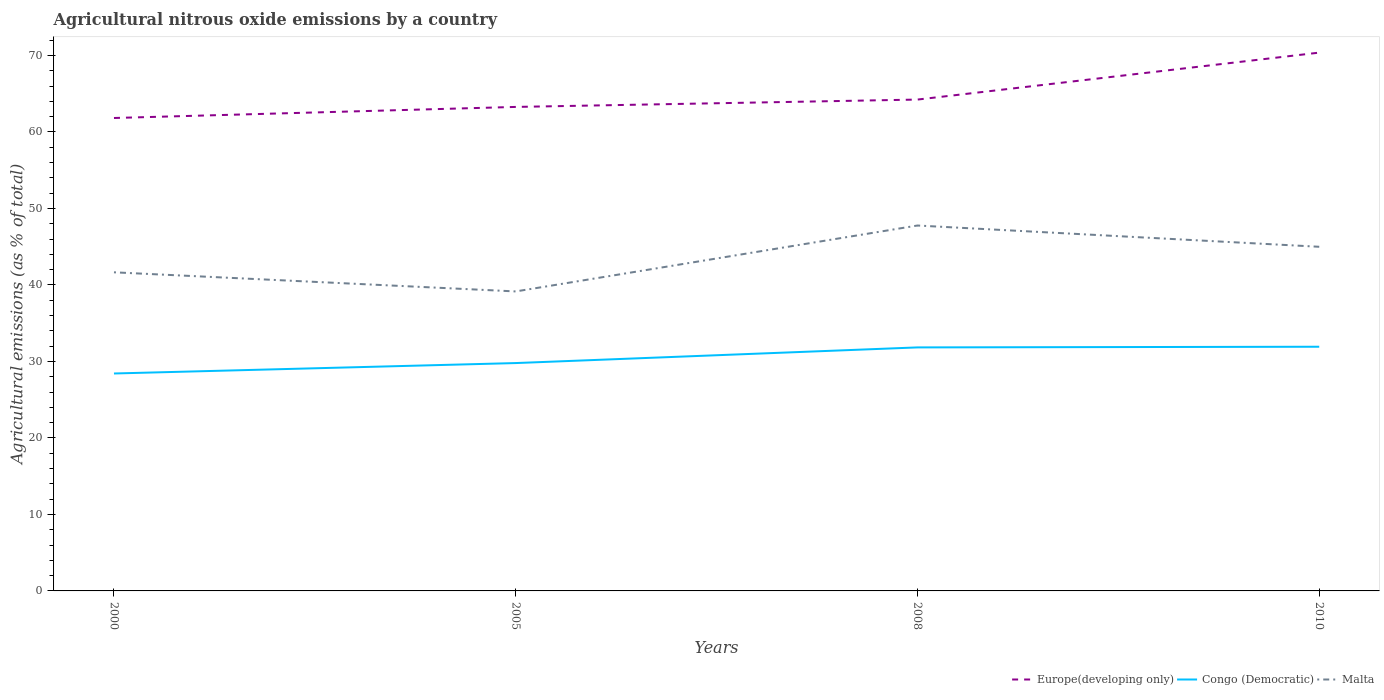Across all years, what is the maximum amount of agricultural nitrous oxide emitted in Malta?
Your answer should be very brief. 39.15. In which year was the amount of agricultural nitrous oxide emitted in Congo (Democratic) maximum?
Make the answer very short. 2000. What is the total amount of agricultural nitrous oxide emitted in Malta in the graph?
Provide a succinct answer. -5.84. What is the difference between the highest and the second highest amount of agricultural nitrous oxide emitted in Malta?
Your response must be concise. 8.62. What is the difference between the highest and the lowest amount of agricultural nitrous oxide emitted in Congo (Democratic)?
Give a very brief answer. 2. Is the amount of agricultural nitrous oxide emitted in Europe(developing only) strictly greater than the amount of agricultural nitrous oxide emitted in Malta over the years?
Offer a terse response. No. Are the values on the major ticks of Y-axis written in scientific E-notation?
Your answer should be compact. No. Does the graph contain grids?
Keep it short and to the point. No. How are the legend labels stacked?
Offer a terse response. Horizontal. What is the title of the graph?
Give a very brief answer. Agricultural nitrous oxide emissions by a country. Does "Malta" appear as one of the legend labels in the graph?
Offer a terse response. Yes. What is the label or title of the X-axis?
Your response must be concise. Years. What is the label or title of the Y-axis?
Your response must be concise. Agricultural emissions (as % of total). What is the Agricultural emissions (as % of total) of Europe(developing only) in 2000?
Offer a very short reply. 61.83. What is the Agricultural emissions (as % of total) of Congo (Democratic) in 2000?
Offer a terse response. 28.43. What is the Agricultural emissions (as % of total) of Malta in 2000?
Provide a succinct answer. 41.65. What is the Agricultural emissions (as % of total) of Europe(developing only) in 2005?
Provide a short and direct response. 63.28. What is the Agricultural emissions (as % of total) in Congo (Democratic) in 2005?
Your answer should be very brief. 29.79. What is the Agricultural emissions (as % of total) of Malta in 2005?
Give a very brief answer. 39.15. What is the Agricultural emissions (as % of total) in Europe(developing only) in 2008?
Offer a very short reply. 64.24. What is the Agricultural emissions (as % of total) of Congo (Democratic) in 2008?
Ensure brevity in your answer.  31.84. What is the Agricultural emissions (as % of total) of Malta in 2008?
Offer a terse response. 47.77. What is the Agricultural emissions (as % of total) of Europe(developing only) in 2010?
Your answer should be very brief. 70.38. What is the Agricultural emissions (as % of total) of Congo (Democratic) in 2010?
Offer a terse response. 31.92. What is the Agricultural emissions (as % of total) in Malta in 2010?
Offer a terse response. 44.99. Across all years, what is the maximum Agricultural emissions (as % of total) in Europe(developing only)?
Provide a succinct answer. 70.38. Across all years, what is the maximum Agricultural emissions (as % of total) in Congo (Democratic)?
Your answer should be compact. 31.92. Across all years, what is the maximum Agricultural emissions (as % of total) of Malta?
Ensure brevity in your answer.  47.77. Across all years, what is the minimum Agricultural emissions (as % of total) of Europe(developing only)?
Make the answer very short. 61.83. Across all years, what is the minimum Agricultural emissions (as % of total) of Congo (Democratic)?
Provide a succinct answer. 28.43. Across all years, what is the minimum Agricultural emissions (as % of total) of Malta?
Offer a terse response. 39.15. What is the total Agricultural emissions (as % of total) in Europe(developing only) in the graph?
Your response must be concise. 259.72. What is the total Agricultural emissions (as % of total) in Congo (Democratic) in the graph?
Offer a terse response. 121.98. What is the total Agricultural emissions (as % of total) in Malta in the graph?
Offer a very short reply. 173.57. What is the difference between the Agricultural emissions (as % of total) in Europe(developing only) in 2000 and that in 2005?
Ensure brevity in your answer.  -1.45. What is the difference between the Agricultural emissions (as % of total) of Congo (Democratic) in 2000 and that in 2005?
Provide a succinct answer. -1.36. What is the difference between the Agricultural emissions (as % of total) of Malta in 2000 and that in 2005?
Your response must be concise. 2.5. What is the difference between the Agricultural emissions (as % of total) of Europe(developing only) in 2000 and that in 2008?
Provide a succinct answer. -2.41. What is the difference between the Agricultural emissions (as % of total) of Congo (Democratic) in 2000 and that in 2008?
Provide a short and direct response. -3.41. What is the difference between the Agricultural emissions (as % of total) of Malta in 2000 and that in 2008?
Provide a short and direct response. -6.12. What is the difference between the Agricultural emissions (as % of total) of Europe(developing only) in 2000 and that in 2010?
Your answer should be very brief. -8.55. What is the difference between the Agricultural emissions (as % of total) of Congo (Democratic) in 2000 and that in 2010?
Your answer should be compact. -3.5. What is the difference between the Agricultural emissions (as % of total) in Malta in 2000 and that in 2010?
Provide a succinct answer. -3.34. What is the difference between the Agricultural emissions (as % of total) of Europe(developing only) in 2005 and that in 2008?
Your response must be concise. -0.96. What is the difference between the Agricultural emissions (as % of total) of Congo (Democratic) in 2005 and that in 2008?
Make the answer very short. -2.05. What is the difference between the Agricultural emissions (as % of total) in Malta in 2005 and that in 2008?
Give a very brief answer. -8.62. What is the difference between the Agricultural emissions (as % of total) of Europe(developing only) in 2005 and that in 2010?
Give a very brief answer. -7.1. What is the difference between the Agricultural emissions (as % of total) in Congo (Democratic) in 2005 and that in 2010?
Keep it short and to the point. -2.13. What is the difference between the Agricultural emissions (as % of total) in Malta in 2005 and that in 2010?
Provide a short and direct response. -5.84. What is the difference between the Agricultural emissions (as % of total) of Europe(developing only) in 2008 and that in 2010?
Provide a short and direct response. -6.14. What is the difference between the Agricultural emissions (as % of total) of Congo (Democratic) in 2008 and that in 2010?
Provide a succinct answer. -0.09. What is the difference between the Agricultural emissions (as % of total) of Malta in 2008 and that in 2010?
Keep it short and to the point. 2.78. What is the difference between the Agricultural emissions (as % of total) in Europe(developing only) in 2000 and the Agricultural emissions (as % of total) in Congo (Democratic) in 2005?
Give a very brief answer. 32.04. What is the difference between the Agricultural emissions (as % of total) of Europe(developing only) in 2000 and the Agricultural emissions (as % of total) of Malta in 2005?
Your answer should be compact. 22.68. What is the difference between the Agricultural emissions (as % of total) of Congo (Democratic) in 2000 and the Agricultural emissions (as % of total) of Malta in 2005?
Keep it short and to the point. -10.73. What is the difference between the Agricultural emissions (as % of total) in Europe(developing only) in 2000 and the Agricultural emissions (as % of total) in Congo (Democratic) in 2008?
Your answer should be compact. 29.99. What is the difference between the Agricultural emissions (as % of total) of Europe(developing only) in 2000 and the Agricultural emissions (as % of total) of Malta in 2008?
Offer a terse response. 14.06. What is the difference between the Agricultural emissions (as % of total) in Congo (Democratic) in 2000 and the Agricultural emissions (as % of total) in Malta in 2008?
Ensure brevity in your answer.  -19.35. What is the difference between the Agricultural emissions (as % of total) of Europe(developing only) in 2000 and the Agricultural emissions (as % of total) of Congo (Democratic) in 2010?
Give a very brief answer. 29.91. What is the difference between the Agricultural emissions (as % of total) in Europe(developing only) in 2000 and the Agricultural emissions (as % of total) in Malta in 2010?
Give a very brief answer. 16.84. What is the difference between the Agricultural emissions (as % of total) in Congo (Democratic) in 2000 and the Agricultural emissions (as % of total) in Malta in 2010?
Provide a short and direct response. -16.57. What is the difference between the Agricultural emissions (as % of total) of Europe(developing only) in 2005 and the Agricultural emissions (as % of total) of Congo (Democratic) in 2008?
Offer a terse response. 31.44. What is the difference between the Agricultural emissions (as % of total) of Europe(developing only) in 2005 and the Agricultural emissions (as % of total) of Malta in 2008?
Your answer should be compact. 15.5. What is the difference between the Agricultural emissions (as % of total) in Congo (Democratic) in 2005 and the Agricultural emissions (as % of total) in Malta in 2008?
Offer a terse response. -17.98. What is the difference between the Agricultural emissions (as % of total) of Europe(developing only) in 2005 and the Agricultural emissions (as % of total) of Congo (Democratic) in 2010?
Your response must be concise. 31.35. What is the difference between the Agricultural emissions (as % of total) in Europe(developing only) in 2005 and the Agricultural emissions (as % of total) in Malta in 2010?
Offer a terse response. 18.29. What is the difference between the Agricultural emissions (as % of total) in Congo (Democratic) in 2005 and the Agricultural emissions (as % of total) in Malta in 2010?
Your response must be concise. -15.2. What is the difference between the Agricultural emissions (as % of total) in Europe(developing only) in 2008 and the Agricultural emissions (as % of total) in Congo (Democratic) in 2010?
Offer a terse response. 32.31. What is the difference between the Agricultural emissions (as % of total) in Europe(developing only) in 2008 and the Agricultural emissions (as % of total) in Malta in 2010?
Offer a very short reply. 19.25. What is the difference between the Agricultural emissions (as % of total) in Congo (Democratic) in 2008 and the Agricultural emissions (as % of total) in Malta in 2010?
Your answer should be very brief. -13.16. What is the average Agricultural emissions (as % of total) in Europe(developing only) per year?
Ensure brevity in your answer.  64.93. What is the average Agricultural emissions (as % of total) of Congo (Democratic) per year?
Offer a very short reply. 30.49. What is the average Agricultural emissions (as % of total) in Malta per year?
Offer a terse response. 43.39. In the year 2000, what is the difference between the Agricultural emissions (as % of total) in Europe(developing only) and Agricultural emissions (as % of total) in Congo (Democratic)?
Give a very brief answer. 33.4. In the year 2000, what is the difference between the Agricultural emissions (as % of total) in Europe(developing only) and Agricultural emissions (as % of total) in Malta?
Ensure brevity in your answer.  20.18. In the year 2000, what is the difference between the Agricultural emissions (as % of total) of Congo (Democratic) and Agricultural emissions (as % of total) of Malta?
Offer a terse response. -13.23. In the year 2005, what is the difference between the Agricultural emissions (as % of total) in Europe(developing only) and Agricultural emissions (as % of total) in Congo (Democratic)?
Provide a succinct answer. 33.49. In the year 2005, what is the difference between the Agricultural emissions (as % of total) of Europe(developing only) and Agricultural emissions (as % of total) of Malta?
Make the answer very short. 24.12. In the year 2005, what is the difference between the Agricultural emissions (as % of total) in Congo (Democratic) and Agricultural emissions (as % of total) in Malta?
Make the answer very short. -9.37. In the year 2008, what is the difference between the Agricultural emissions (as % of total) in Europe(developing only) and Agricultural emissions (as % of total) in Congo (Democratic)?
Your answer should be compact. 32.4. In the year 2008, what is the difference between the Agricultural emissions (as % of total) in Europe(developing only) and Agricultural emissions (as % of total) in Malta?
Keep it short and to the point. 16.46. In the year 2008, what is the difference between the Agricultural emissions (as % of total) of Congo (Democratic) and Agricultural emissions (as % of total) of Malta?
Keep it short and to the point. -15.94. In the year 2010, what is the difference between the Agricultural emissions (as % of total) in Europe(developing only) and Agricultural emissions (as % of total) in Congo (Democratic)?
Provide a short and direct response. 38.45. In the year 2010, what is the difference between the Agricultural emissions (as % of total) in Europe(developing only) and Agricultural emissions (as % of total) in Malta?
Offer a terse response. 25.38. In the year 2010, what is the difference between the Agricultural emissions (as % of total) of Congo (Democratic) and Agricultural emissions (as % of total) of Malta?
Ensure brevity in your answer.  -13.07. What is the ratio of the Agricultural emissions (as % of total) in Europe(developing only) in 2000 to that in 2005?
Your answer should be compact. 0.98. What is the ratio of the Agricultural emissions (as % of total) of Congo (Democratic) in 2000 to that in 2005?
Provide a short and direct response. 0.95. What is the ratio of the Agricultural emissions (as % of total) of Malta in 2000 to that in 2005?
Your answer should be compact. 1.06. What is the ratio of the Agricultural emissions (as % of total) in Europe(developing only) in 2000 to that in 2008?
Offer a very short reply. 0.96. What is the ratio of the Agricultural emissions (as % of total) of Congo (Democratic) in 2000 to that in 2008?
Give a very brief answer. 0.89. What is the ratio of the Agricultural emissions (as % of total) in Malta in 2000 to that in 2008?
Provide a short and direct response. 0.87. What is the ratio of the Agricultural emissions (as % of total) of Europe(developing only) in 2000 to that in 2010?
Your answer should be very brief. 0.88. What is the ratio of the Agricultural emissions (as % of total) in Congo (Democratic) in 2000 to that in 2010?
Make the answer very short. 0.89. What is the ratio of the Agricultural emissions (as % of total) in Malta in 2000 to that in 2010?
Your answer should be very brief. 0.93. What is the ratio of the Agricultural emissions (as % of total) of Congo (Democratic) in 2005 to that in 2008?
Provide a succinct answer. 0.94. What is the ratio of the Agricultural emissions (as % of total) in Malta in 2005 to that in 2008?
Provide a succinct answer. 0.82. What is the ratio of the Agricultural emissions (as % of total) in Europe(developing only) in 2005 to that in 2010?
Keep it short and to the point. 0.9. What is the ratio of the Agricultural emissions (as % of total) of Congo (Democratic) in 2005 to that in 2010?
Your response must be concise. 0.93. What is the ratio of the Agricultural emissions (as % of total) of Malta in 2005 to that in 2010?
Ensure brevity in your answer.  0.87. What is the ratio of the Agricultural emissions (as % of total) in Europe(developing only) in 2008 to that in 2010?
Keep it short and to the point. 0.91. What is the ratio of the Agricultural emissions (as % of total) of Malta in 2008 to that in 2010?
Provide a short and direct response. 1.06. What is the difference between the highest and the second highest Agricultural emissions (as % of total) of Europe(developing only)?
Provide a short and direct response. 6.14. What is the difference between the highest and the second highest Agricultural emissions (as % of total) of Congo (Democratic)?
Your answer should be compact. 0.09. What is the difference between the highest and the second highest Agricultural emissions (as % of total) in Malta?
Keep it short and to the point. 2.78. What is the difference between the highest and the lowest Agricultural emissions (as % of total) in Europe(developing only)?
Make the answer very short. 8.55. What is the difference between the highest and the lowest Agricultural emissions (as % of total) of Congo (Democratic)?
Provide a short and direct response. 3.5. What is the difference between the highest and the lowest Agricultural emissions (as % of total) of Malta?
Give a very brief answer. 8.62. 